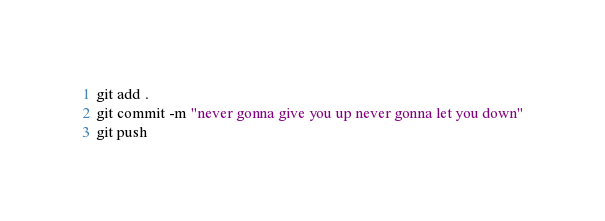Convert code to text. <code><loc_0><loc_0><loc_500><loc_500><_Bash_>git add .
git commit -m "never gonna give you up never gonna let you down"
git push 
</code> 